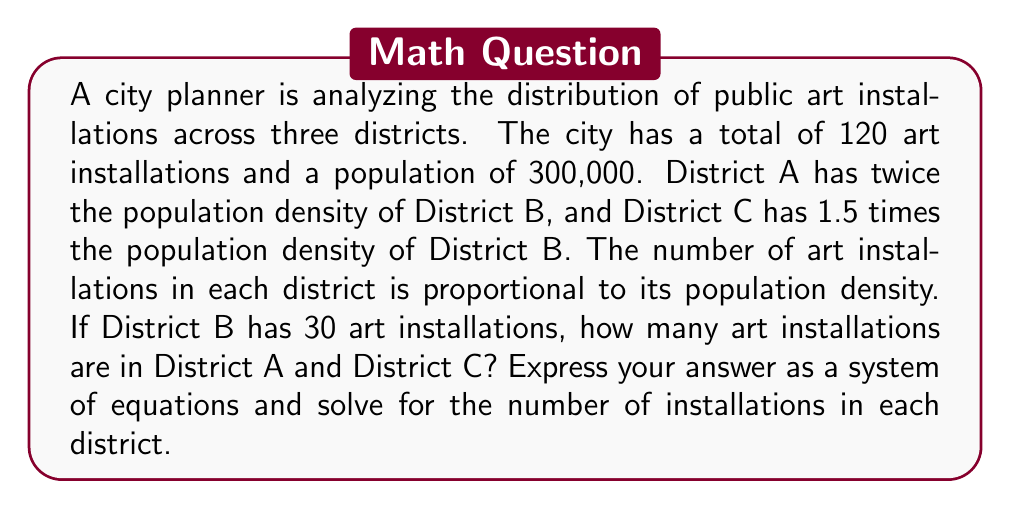Can you answer this question? Let's approach this step-by-step:

1) Let $x$, $y$, and $z$ represent the number of art installations in Districts A, B, and C respectively.

2) We know that District B has 30 installations, so $y = 30$.

3) The total number of installations is 120, so we can write:

   $x + y + z = 120$

4) The number of installations is proportional to population density. Let's express this mathematically:

   For District A: $x = 2k$
   For District B: $y = k$
   For District C: $z = 1.5k$

   Where $k$ is some constant of proportionality.

5) We can now set up our system of equations:

   $$\begin{cases}
   x + y + z = 120 \\
   x = 2y \\
   z = 1.5y \\
   y = 30
   \end{cases}$$

6) Substituting the known value of $y$ and the expressions for $x$ and $z$ in terms of $y$ into the first equation:

   $2y + y + 1.5y = 120$
   $4.5y = 120$

7) Solving for $y$:

   $y = 120 / 4.5 = 26.67$

   But we know $y = 30$, which confirms our setup.

8) Now we can solve for $x$ and $z$:

   $x = 2y = 2(30) = 60$
   $z = 1.5y = 1.5(30) = 45$

9) We can verify: $60 + 30 + 45 = 135$, which equals our total of 120 installations.
Answer: The system of equations is:

$$\begin{cases}
x + y + z = 120 \\
x = 2y \\
z = 1.5y \\
y = 30
\end{cases}$$

Solving this system yields:
District A: 60 installations
District B: 30 installations
District C: 45 installations 